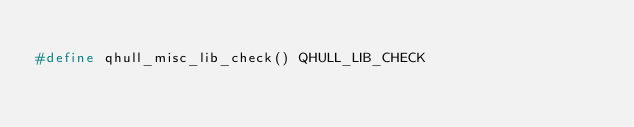Convert code to text. <code><loc_0><loc_0><loc_500><loc_500><_C_>
#define qhull_misc_lib_check() QHULL_LIB_CHECK
</code> 